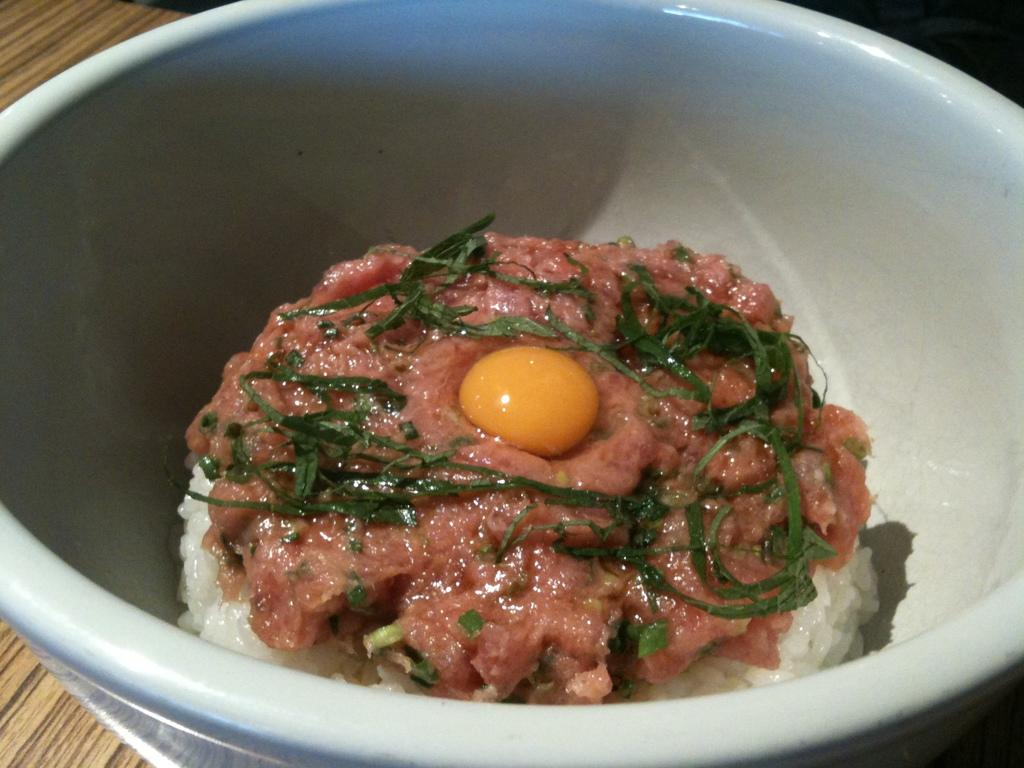What is in the bowl that is visible in the image? There is boiled rice in the bowl. What else can be seen in the bowl besides the rice? There are food items in the bowl, and egg yolk is on top of the food items. What is sprinkled on top of the egg yolk? Green vegetable leaves are sprinkled on top of the egg yolk. What is the bowl placed on in the image? The bowl is on a wooden object. What type of paper is visible in the image? There is no paper present in the image. Can you see any ants in the image? There are no ants visible in the image. 